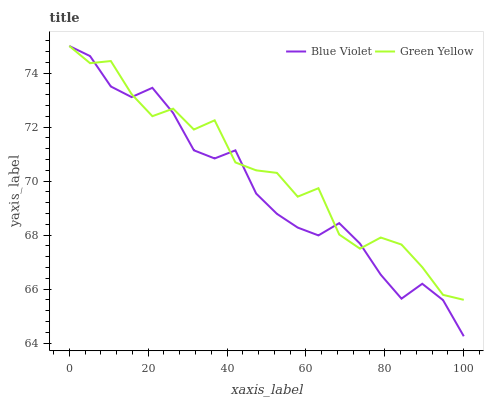Does Blue Violet have the minimum area under the curve?
Answer yes or no. Yes. Does Green Yellow have the maximum area under the curve?
Answer yes or no. Yes. Does Blue Violet have the maximum area under the curve?
Answer yes or no. No. Is Blue Violet the smoothest?
Answer yes or no. Yes. Is Green Yellow the roughest?
Answer yes or no. Yes. Is Blue Violet the roughest?
Answer yes or no. No. Does Blue Violet have the lowest value?
Answer yes or no. Yes. Does Blue Violet have the highest value?
Answer yes or no. Yes. Does Green Yellow intersect Blue Violet?
Answer yes or no. Yes. Is Green Yellow less than Blue Violet?
Answer yes or no. No. Is Green Yellow greater than Blue Violet?
Answer yes or no. No. 